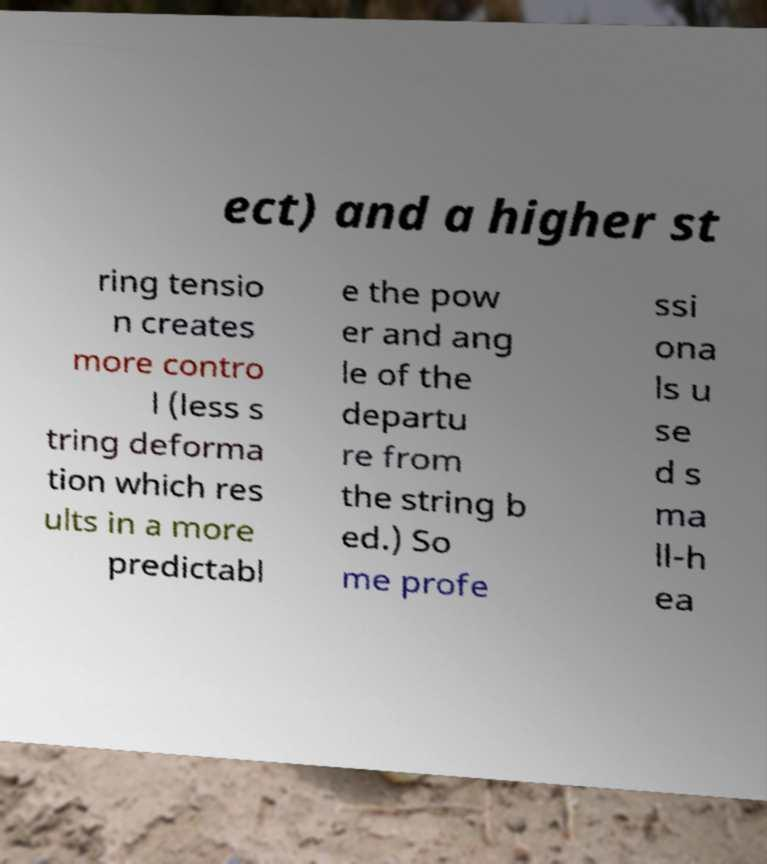Could you extract and type out the text from this image? ect) and a higher st ring tensio n creates more contro l (less s tring deforma tion which res ults in a more predictabl e the pow er and ang le of the departu re from the string b ed.) So me profe ssi ona ls u se d s ma ll-h ea 